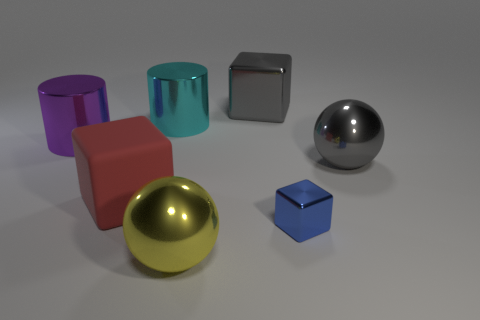Subtract 1 cubes. How many cubes are left? 2 Add 1 big cyan objects. How many objects exist? 8 Subtract all cylinders. How many objects are left? 5 Subtract 1 gray cubes. How many objects are left? 6 Subtract all tiny brown metal cylinders. Subtract all large cyan metallic cylinders. How many objects are left? 6 Add 6 large gray metal things. How many large gray metal things are left? 8 Add 1 large yellow metallic things. How many large yellow metallic things exist? 2 